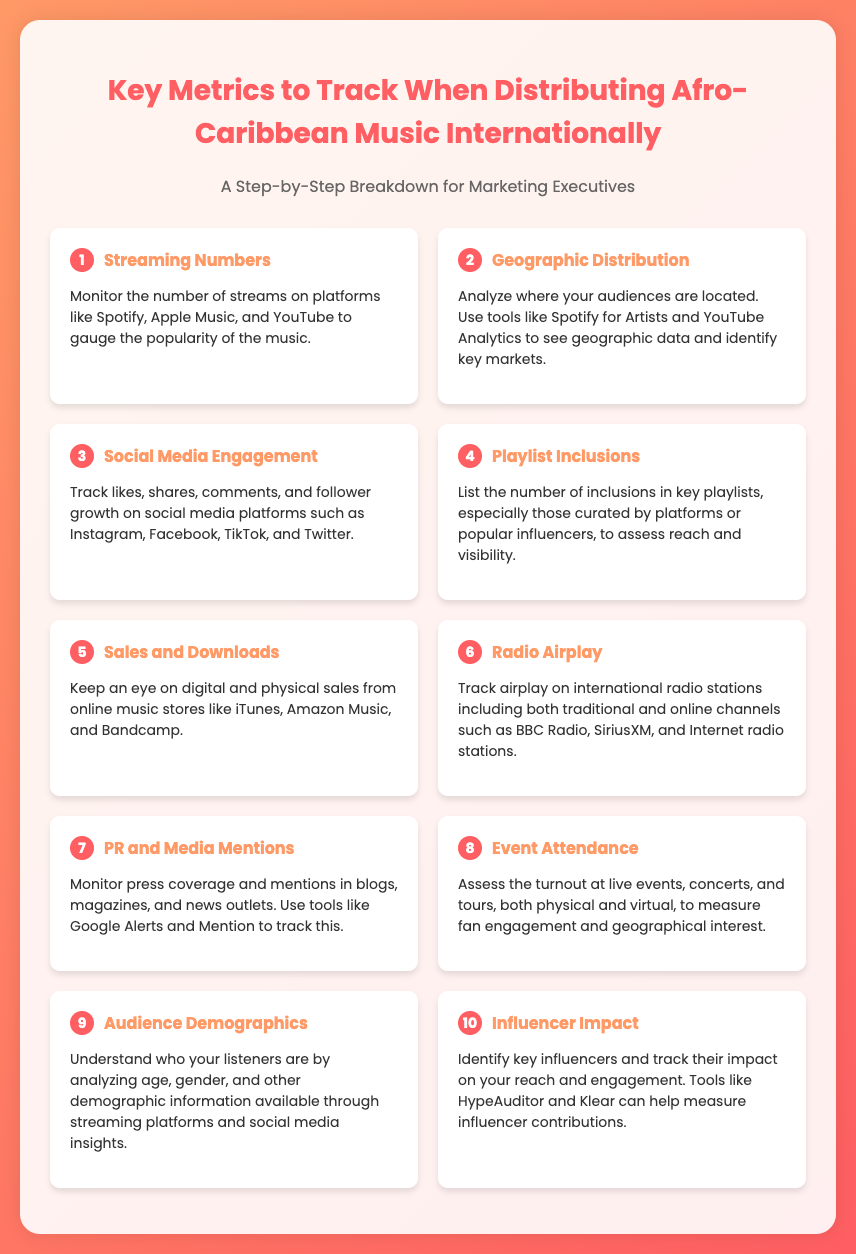What is the first key metric listed? The first key metric is "Streaming Numbers," which is the first item in the list.
Answer: Streaming Numbers What does the second metric analyze? The second metric, "Geographic Distribution," analyzes where the audiences are located.
Answer: Where audiences are located How many metrics are provided in the document? The document lists a total of ten different metrics.
Answer: Ten Which social media platforms are mentioned for engagement tracking? The document mentions Instagram, Facebook, TikTok, and Twitter for tracking engagement.
Answer: Instagram, Facebook, TikTok, Twitter What is the main focus of the 'Event Attendance' metric? The focus of the 'Event Attendance' metric is on assessing turnout at live events, concerts, and tours.
Answer: Assessing turnout What type of airplay does the 'Radio Airplay' metric cover? The 'Radio Airplay' metric covers both traditional and online channels.
Answer: Traditional and online channels Which tools are suggested for tracking PR and media mentions? The document suggests using Google Alerts and Mention for tracking press coverage and mentions.
Answer: Google Alerts and Mention What demographic information should be analyzed according to the ninth metric? The ninth metric advises analyzing age, gender, and other demographic information.
Answer: Age, gender, demographics What is the purpose of the 'Influencer Impact' metric? The purpose of the 'Influencer Impact' metric is to identify key influencers and track their impact on reach and engagement.
Answer: Identify key influencers and track impact 